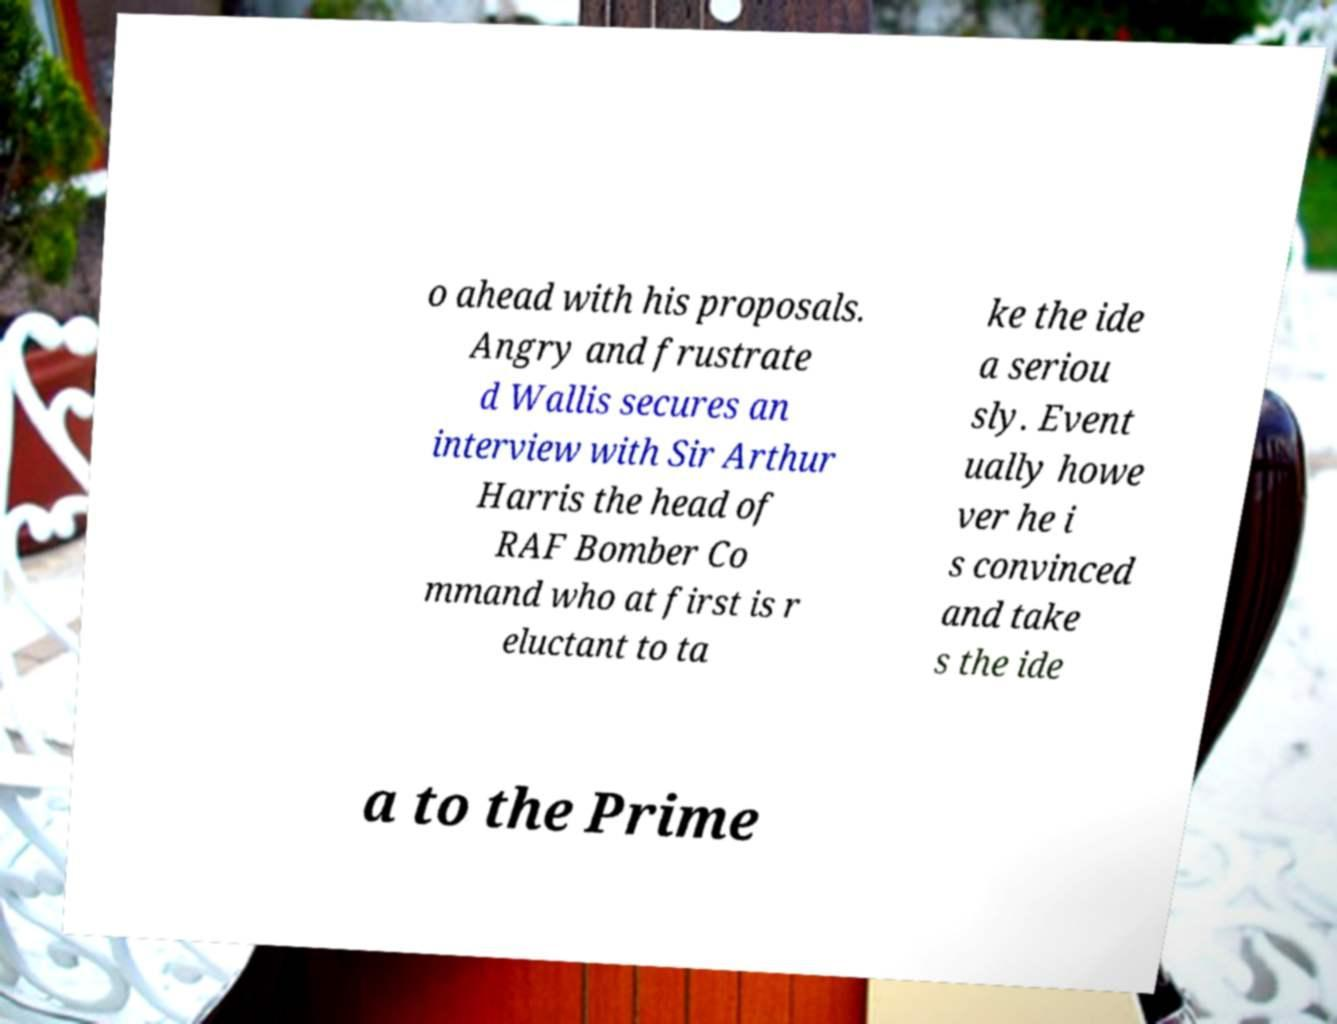There's text embedded in this image that I need extracted. Can you transcribe it verbatim? o ahead with his proposals. Angry and frustrate d Wallis secures an interview with Sir Arthur Harris the head of RAF Bomber Co mmand who at first is r eluctant to ta ke the ide a seriou sly. Event ually howe ver he i s convinced and take s the ide a to the Prime 